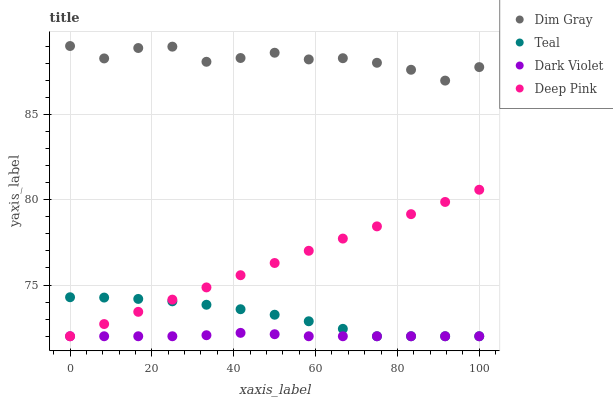Does Dark Violet have the minimum area under the curve?
Answer yes or no. Yes. Does Dim Gray have the maximum area under the curve?
Answer yes or no. Yes. Does Teal have the minimum area under the curve?
Answer yes or no. No. Does Teal have the maximum area under the curve?
Answer yes or no. No. Is Deep Pink the smoothest?
Answer yes or no. Yes. Is Dim Gray the roughest?
Answer yes or no. Yes. Is Dark Violet the smoothest?
Answer yes or no. No. Is Dark Violet the roughest?
Answer yes or no. No. Does Dark Violet have the lowest value?
Answer yes or no. Yes. Does Dim Gray have the highest value?
Answer yes or no. Yes. Does Teal have the highest value?
Answer yes or no. No. Is Dark Violet less than Dim Gray?
Answer yes or no. Yes. Is Dim Gray greater than Teal?
Answer yes or no. Yes. Does Teal intersect Deep Pink?
Answer yes or no. Yes. Is Teal less than Deep Pink?
Answer yes or no. No. Is Teal greater than Deep Pink?
Answer yes or no. No. Does Dark Violet intersect Dim Gray?
Answer yes or no. No. 